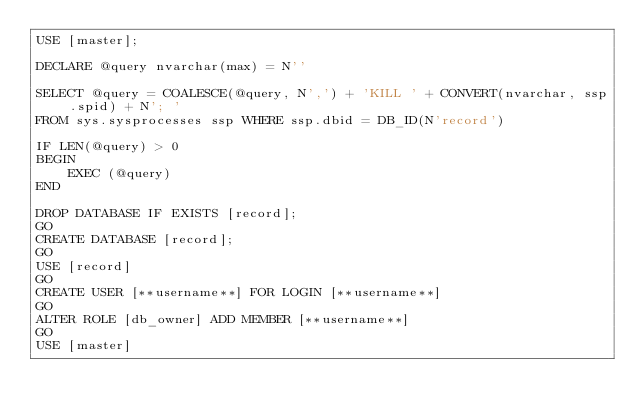<code> <loc_0><loc_0><loc_500><loc_500><_SQL_>USE [master];

DECLARE @query nvarchar(max) = N''

SELECT @query = COALESCE(@query, N',') + 'KILL ' + CONVERT(nvarchar, ssp.spid) + N'; '
FROM sys.sysprocesses ssp WHERE ssp.dbid = DB_ID(N'record')

IF LEN(@query) > 0
BEGIN
    EXEC (@query)
END

DROP DATABASE IF EXISTS [record];
GO
CREATE DATABASE [record];
GO
USE [record]
GO
CREATE USER [**username**] FOR LOGIN [**username**]
GO
ALTER ROLE [db_owner] ADD MEMBER [**username**]
GO
USE [master]
</code> 